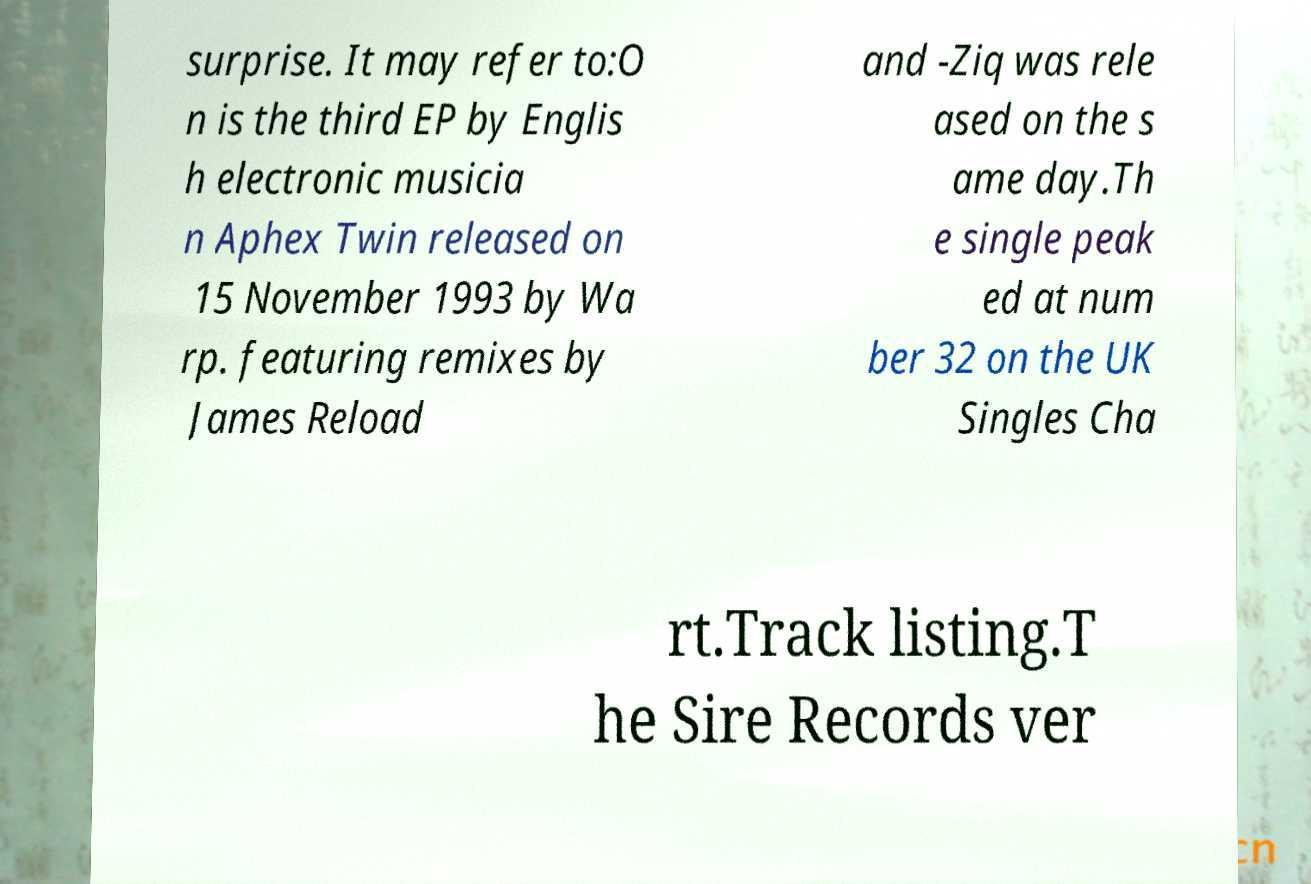There's text embedded in this image that I need extracted. Can you transcribe it verbatim? surprise. It may refer to:O n is the third EP by Englis h electronic musicia n Aphex Twin released on 15 November 1993 by Wa rp. featuring remixes by James Reload and -Ziq was rele ased on the s ame day.Th e single peak ed at num ber 32 on the UK Singles Cha rt.Track listing.T he Sire Records ver 